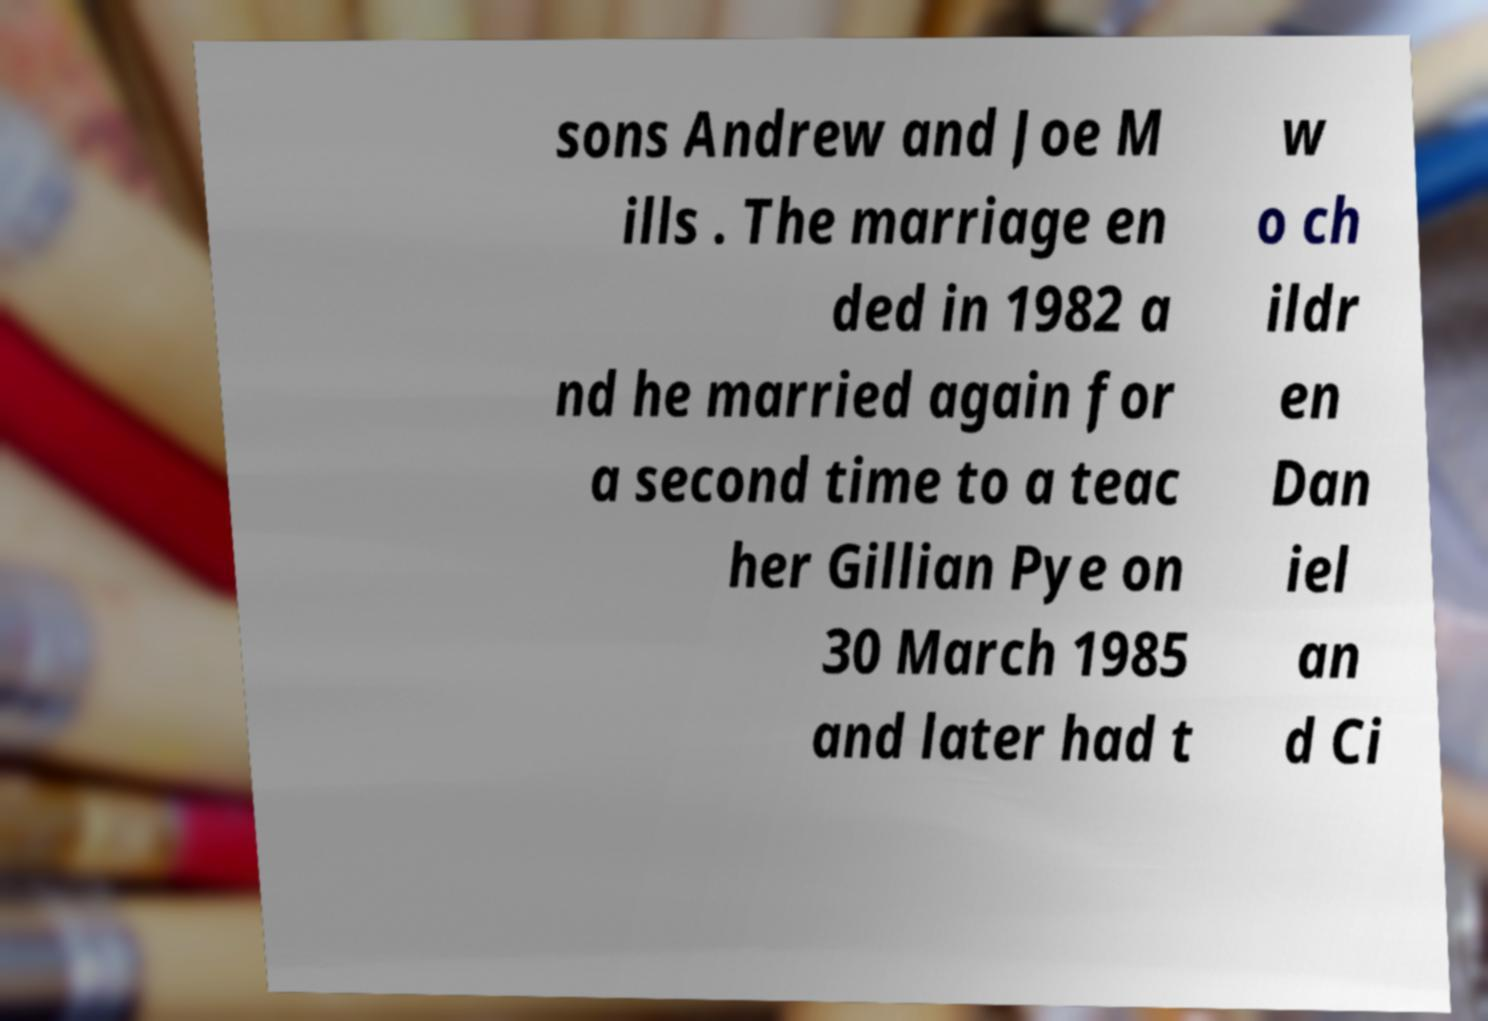Could you assist in decoding the text presented in this image and type it out clearly? sons Andrew and Joe M ills . The marriage en ded in 1982 a nd he married again for a second time to a teac her Gillian Pye on 30 March 1985 and later had t w o ch ildr en Dan iel an d Ci 